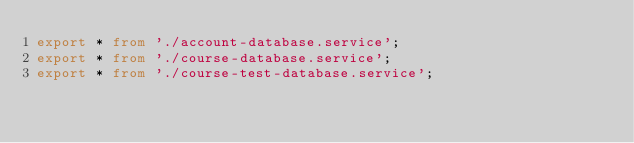Convert code to text. <code><loc_0><loc_0><loc_500><loc_500><_TypeScript_>export * from './account-database.service';
export * from './course-database.service';
export * from './course-test-database.service';
</code> 